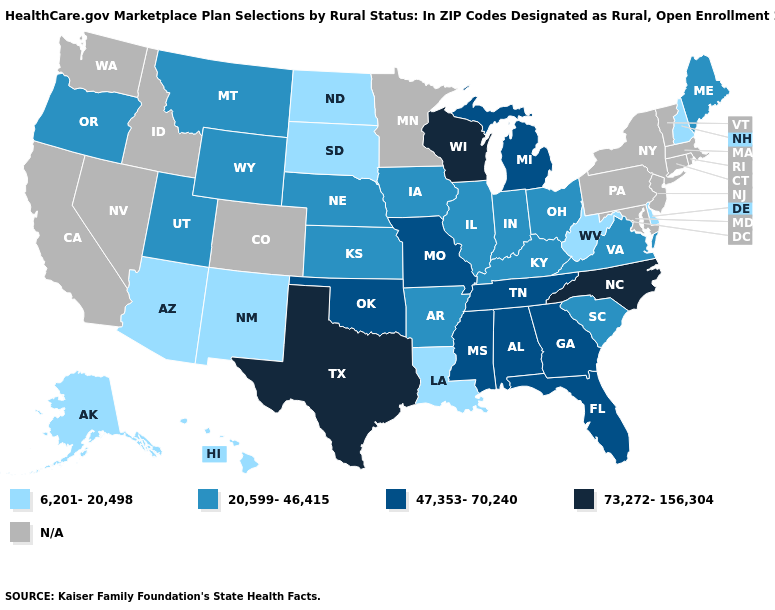Does the first symbol in the legend represent the smallest category?
Concise answer only. Yes. Does Kansas have the highest value in the MidWest?
Write a very short answer. No. Name the states that have a value in the range 20,599-46,415?
Write a very short answer. Arkansas, Illinois, Indiana, Iowa, Kansas, Kentucky, Maine, Montana, Nebraska, Ohio, Oregon, South Carolina, Utah, Virginia, Wyoming. Which states have the lowest value in the South?
Answer briefly. Delaware, Louisiana, West Virginia. What is the value of South Dakota?
Short answer required. 6,201-20,498. What is the value of Kentucky?
Quick response, please. 20,599-46,415. Which states hav the highest value in the West?
Write a very short answer. Montana, Oregon, Utah, Wyoming. Name the states that have a value in the range 20,599-46,415?
Concise answer only. Arkansas, Illinois, Indiana, Iowa, Kansas, Kentucky, Maine, Montana, Nebraska, Ohio, Oregon, South Carolina, Utah, Virginia, Wyoming. Which states hav the highest value in the MidWest?
Keep it brief. Wisconsin. What is the value of Arizona?
Short answer required. 6,201-20,498. Does Alaska have the lowest value in the West?
Give a very brief answer. Yes. Name the states that have a value in the range 6,201-20,498?
Keep it brief. Alaska, Arizona, Delaware, Hawaii, Louisiana, New Hampshire, New Mexico, North Dakota, South Dakota, West Virginia. Name the states that have a value in the range 6,201-20,498?
Keep it brief. Alaska, Arizona, Delaware, Hawaii, Louisiana, New Hampshire, New Mexico, North Dakota, South Dakota, West Virginia. 